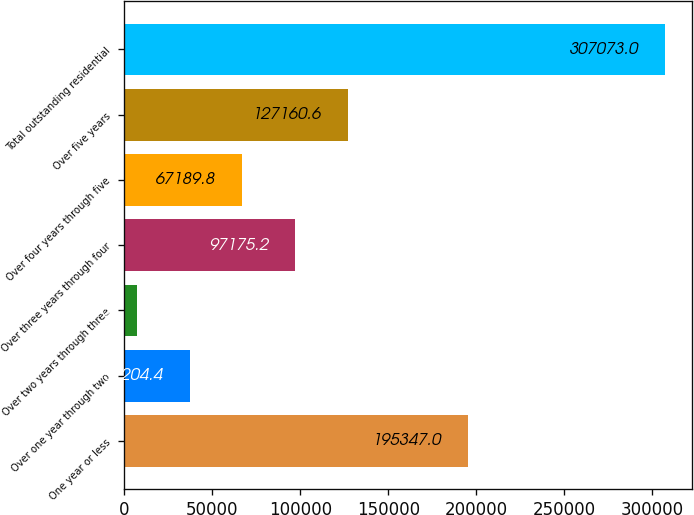Convert chart to OTSL. <chart><loc_0><loc_0><loc_500><loc_500><bar_chart><fcel>One year or less<fcel>Over one year through two<fcel>Over two years through three<fcel>Over three years through four<fcel>Over four years through five<fcel>Over five years<fcel>Total outstanding residential<nl><fcel>195347<fcel>37204.4<fcel>7219<fcel>97175.2<fcel>67189.8<fcel>127161<fcel>307073<nl></chart> 